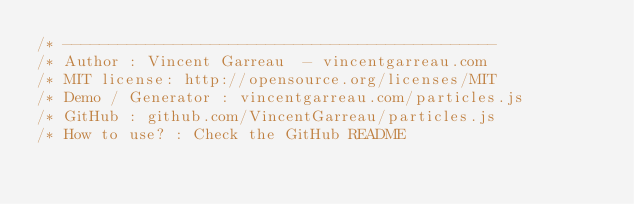<code> <loc_0><loc_0><loc_500><loc_500><_JavaScript_>/* -----------------------------------------------
/* Author : Vincent Garreau  - vincentgarreau.com
/* MIT license: http://opensource.org/licenses/MIT
/* Demo / Generator : vincentgarreau.com/particles.js
/* GitHub : github.com/VincentGarreau/particles.js
/* How to use? : Check the GitHub README</code> 